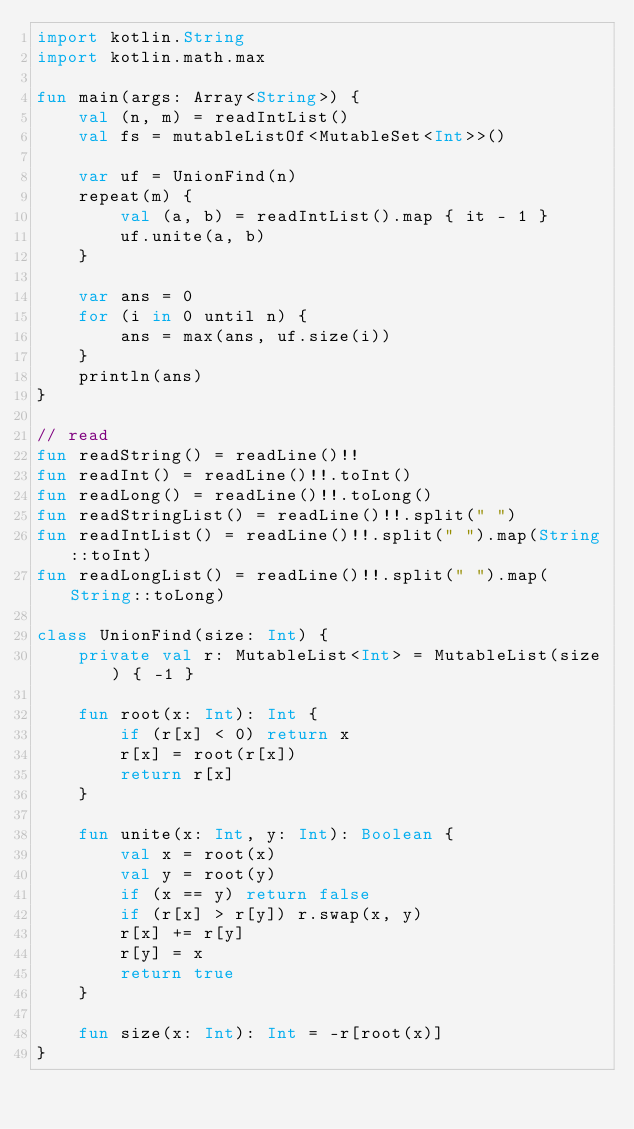Convert code to text. <code><loc_0><loc_0><loc_500><loc_500><_Kotlin_>import kotlin.String
import kotlin.math.max

fun main(args: Array<String>) {
    val (n, m) = readIntList()
    val fs = mutableListOf<MutableSet<Int>>()

    var uf = UnionFind(n)
    repeat(m) {
        val (a, b) = readIntList().map { it - 1 }
        uf.unite(a, b)
    }

    var ans = 0
    for (i in 0 until n) {
        ans = max(ans, uf.size(i))
    }
    println(ans)
}

// read
fun readString() = readLine()!!
fun readInt() = readLine()!!.toInt()
fun readLong() = readLine()!!.toLong()
fun readStringList() = readLine()!!.split(" ")
fun readIntList() = readLine()!!.split(" ").map(String::toInt)
fun readLongList() = readLine()!!.split(" ").map(String::toLong)

class UnionFind(size: Int) {
    private val r: MutableList<Int> = MutableList(size) { -1 }

    fun root(x: Int): Int {
        if (r[x] < 0) return x
        r[x] = root(r[x])
        return r[x]
    }

    fun unite(x: Int, y: Int): Boolean {
        val x = root(x)
        val y = root(y)
        if (x == y) return false
        if (r[x] > r[y]) r.swap(x, y)
        r[x] += r[y]
        r[y] = x
        return true
    }

    fun size(x: Int): Int = -r[root(x)]
}</code> 